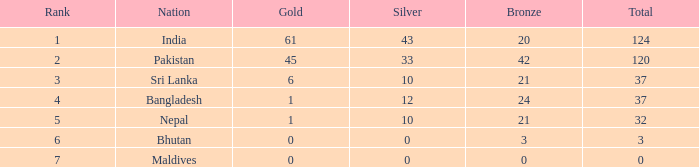Which Gold has a Nation of sri lanka, and a Silver smaller than 10? None. 